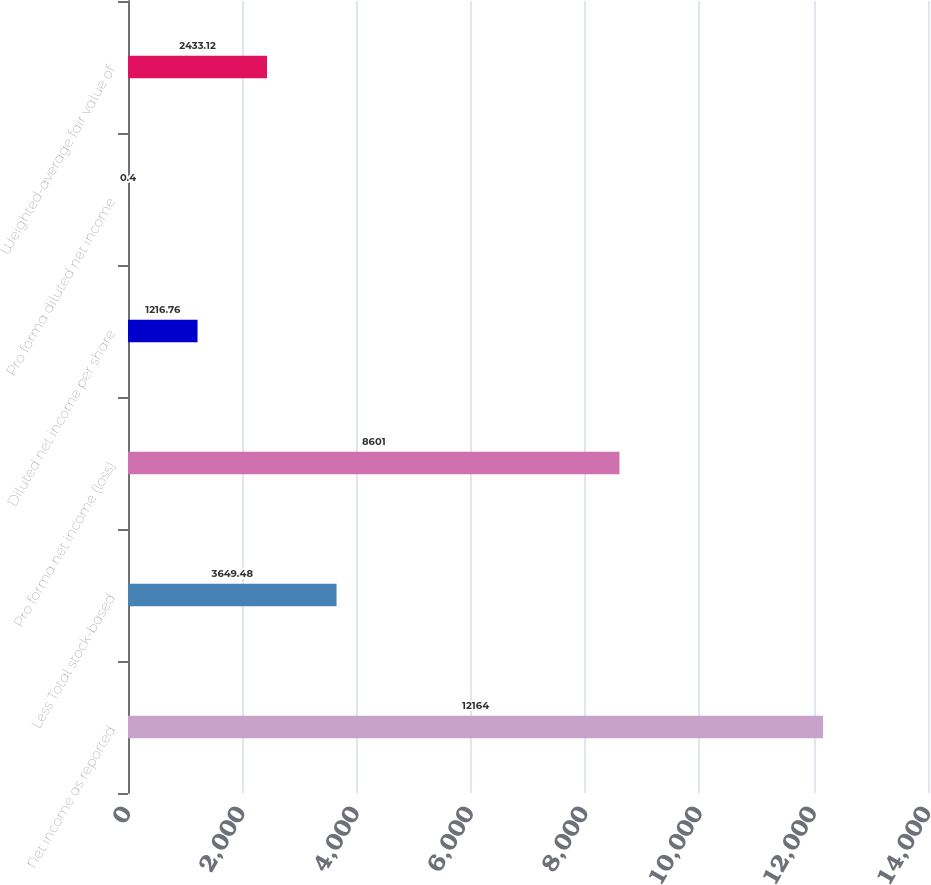Convert chart. <chart><loc_0><loc_0><loc_500><loc_500><bar_chart><fcel>Net income as reported<fcel>Less Total stock-based<fcel>Pro forma net income (loss)<fcel>Diluted net income per share<fcel>Pro forma diluted net income<fcel>Weighted-average fair value of<nl><fcel>12164<fcel>3649.48<fcel>8601<fcel>1216.76<fcel>0.4<fcel>2433.12<nl></chart> 